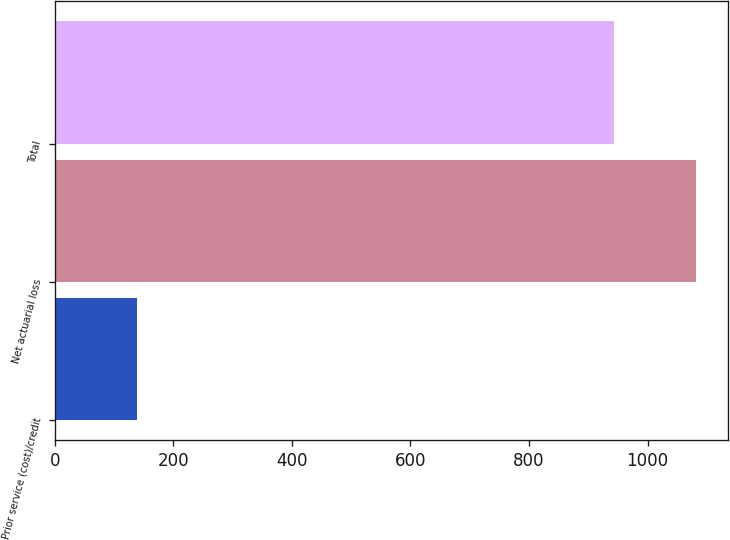Convert chart. <chart><loc_0><loc_0><loc_500><loc_500><bar_chart><fcel>Prior service (cost)/credit<fcel>Net actuarial loss<fcel>Total<nl><fcel>139<fcel>1082<fcel>943<nl></chart> 